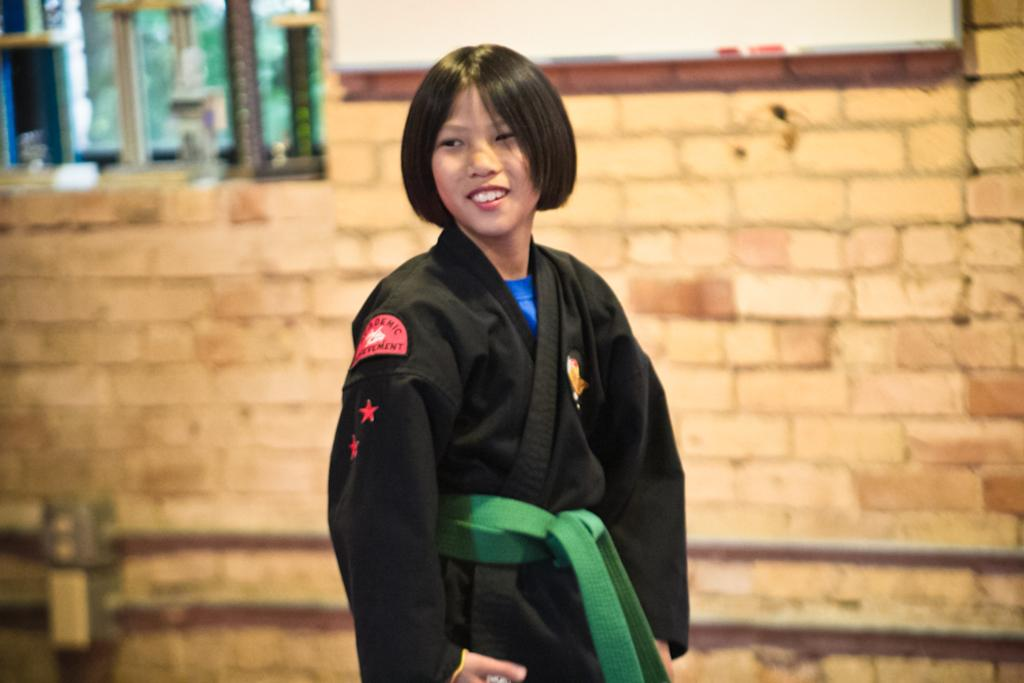Who is the main subject in the image? There is a girl in the center of the image. What is the girl doing in the image? The girl is standing and smiling. What can be seen in the background of the image? There is a wall and a window in the background of the image. What type of crown is the girl wearing in the image? There is no crown present in the image; the girl is not wearing any headwear. What is the girl protesting in the image? There is no protest depicted in the image; the girl is simply standing and smiling. 